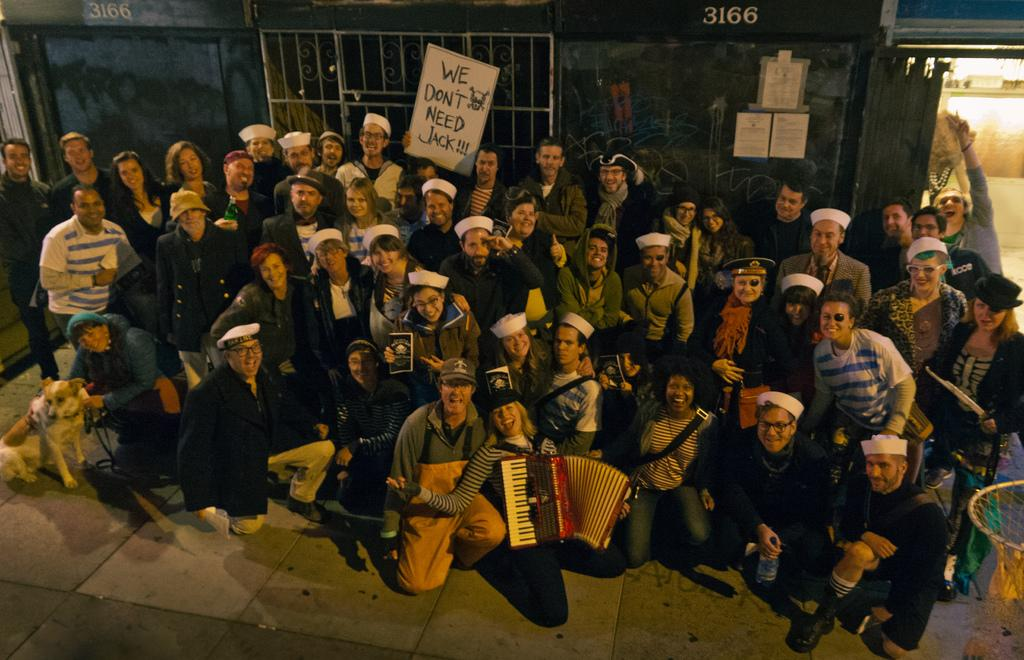How many people are in the image? There is a group of people in the image, but the exact number is not specified. What are the people doing in the image? The people are on a path, which suggests they might be walking or hiking. What are some people holding in the image? Some people are holding objects, but the specific objects are not described. What can be seen at the top of the image? There is a wall, a grille, and posters visible at the top of the image. Are there any doors visible in the image? Yes, there are doors visible at the top of the image. How many goldfish are swimming in the water in the image? There is no water or goldfish present in the image. What type of holiday is being celebrated in the image? There is no indication of a holiday being celebrated in the image. 